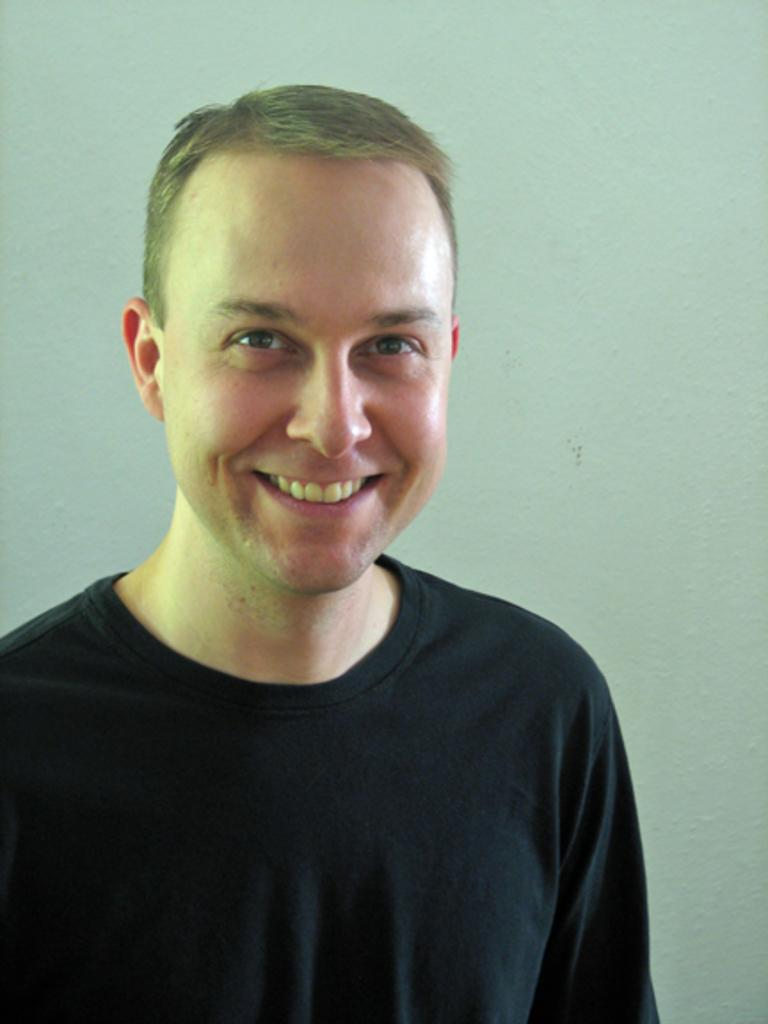Who is present in the image? There is a man in the image. What is the man wearing? The man is wearing a black t-shirt. Where is the man standing? The man is standing in front of a wall. What expression does the man have? The man is smiling. What type of bushes can be seen growing on the man's head in the image? There are no bushes present on the man's head in the image. What things can be seen floating in the air around the man in the image? There are no things floating in the air around the man in the image. 